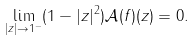Convert formula to latex. <formula><loc_0><loc_0><loc_500><loc_500>\lim _ { | z | \rightarrow 1 ^ { - } } ( 1 - | z | ^ { 2 } ) \mathcal { A } ( f ) ( z ) = 0 .</formula> 